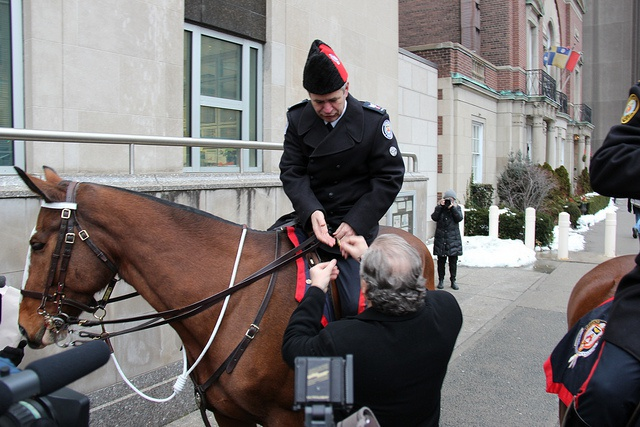Describe the objects in this image and their specific colors. I can see horse in gray, black, maroon, and brown tones, people in gray, black, darkgray, and lightgray tones, people in gray, black, lightgray, and lightpink tones, people in gray, black, and darkgray tones, and horse in gray, maroon, and brown tones in this image. 